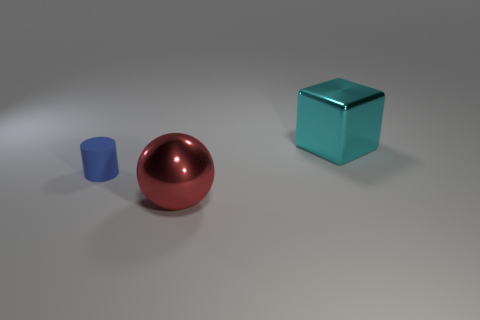Are there any other things that have the same material as the cylinder?
Offer a very short reply. No. Are there any other things that are the same size as the blue cylinder?
Your answer should be very brief. No. Are there an equal number of cubes in front of the shiny block and things that are right of the large metal sphere?
Give a very brief answer. No. Is the number of big cyan cubes that are on the left side of the large red shiny thing the same as the number of tiny gray metal things?
Make the answer very short. Yes. Is the red metallic ball the same size as the rubber thing?
Provide a succinct answer. No. What material is the object that is behind the big red thing and in front of the large cyan shiny block?
Ensure brevity in your answer.  Rubber. What number of blue rubber objects have the same shape as the red thing?
Keep it short and to the point. 0. What material is the big object in front of the big block?
Make the answer very short. Metal. Is the number of blue matte objects that are in front of the big ball less than the number of tiny yellow rubber cylinders?
Offer a terse response. No. Is the big red thing the same shape as the tiny rubber thing?
Make the answer very short. No. 